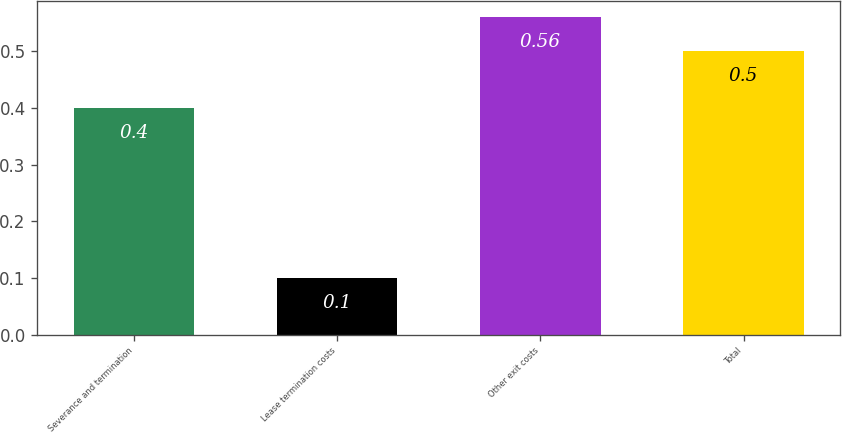Convert chart. <chart><loc_0><loc_0><loc_500><loc_500><bar_chart><fcel>Severance and termination<fcel>Lease termination costs<fcel>Other exit costs<fcel>Total<nl><fcel>0.4<fcel>0.1<fcel>0.56<fcel>0.5<nl></chart> 